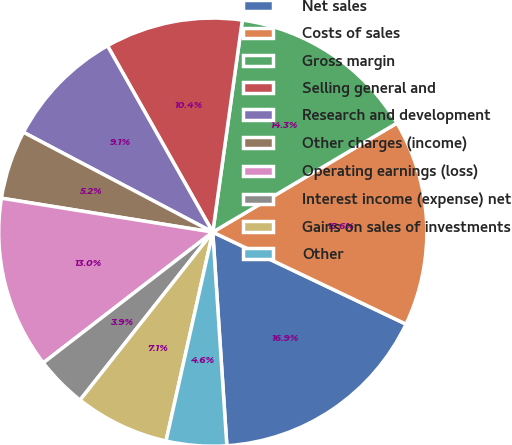<chart> <loc_0><loc_0><loc_500><loc_500><pie_chart><fcel>Net sales<fcel>Costs of sales<fcel>Gross margin<fcel>Selling general and<fcel>Research and development<fcel>Other charges (income)<fcel>Operating earnings (loss)<fcel>Interest income (expense) net<fcel>Gains on sales of investments<fcel>Other<nl><fcel>16.88%<fcel>15.58%<fcel>14.29%<fcel>10.39%<fcel>9.09%<fcel>5.19%<fcel>12.99%<fcel>3.9%<fcel>7.14%<fcel>4.55%<nl></chart> 